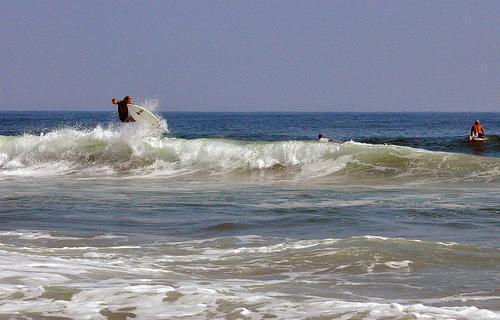How many people are visible?
Give a very brief answer. 3. How many surfboards are shown in the picture?
Give a very brief answer. 2. 